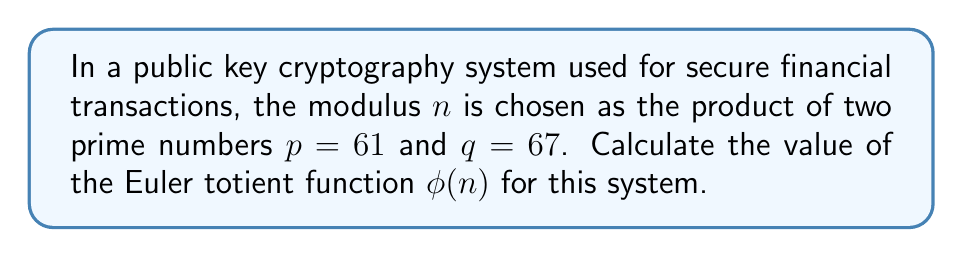Teach me how to tackle this problem. To calculate the Euler totient function $\phi(n)$ for a modulus $n$ used in public key cryptography, we follow these steps:

1) The modulus $n$ is the product of two prime numbers $p$ and $q$:
   $n = p \times q = 61 \times 67 = 4087$

2) For any prime number $a$, the value of $\phi(a)$ is equal to $a - 1$, as all positive integers less than $a$ are coprime to it.

3) The Euler totient function has a multiplicative property: for coprime numbers $a$ and $b$,
   $\phi(ab) = \phi(a) \times \phi(b)$

4) Since $p$ and $q$ are prime, we can use this property:
   $\phi(n) = \phi(p) \times \phi(q)$

5) Calculate $\phi(p)$ and $\phi(q)$:
   $\phi(p) = p - 1 = 61 - 1 = 60$
   $\phi(q) = q - 1 = 67 - 1 = 66$

6) Finally, multiply these values:
   $\phi(n) = \phi(p) \times \phi(q) = 60 \times 66 = 3960$

Therefore, the value of the Euler totient function $\phi(n)$ for this public key cryptography system is 3960.
Answer: $3960$ 